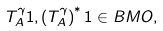Convert formula to latex. <formula><loc_0><loc_0><loc_500><loc_500>T ^ { \gamma } _ { A } 1 , \left ( T ^ { \gamma } _ { A } \right ) ^ { * } 1 \in B M O ,</formula> 